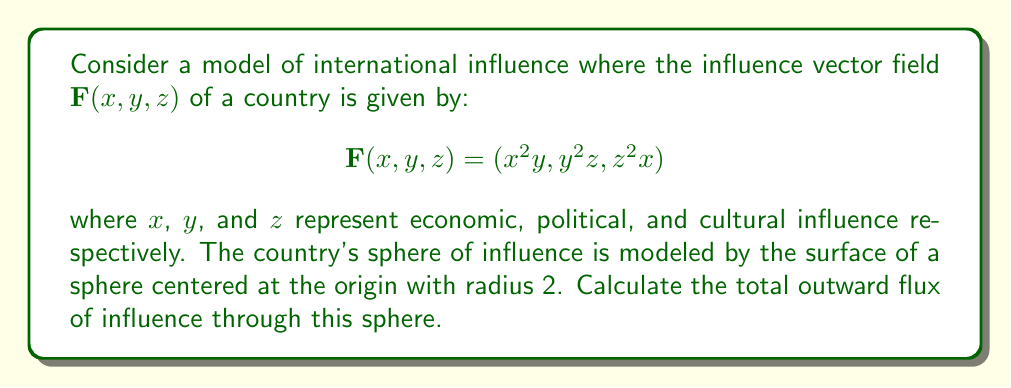Help me with this question. To solve this problem, we'll use the divergence theorem and follow these steps:

1) The divergence theorem states that the flux of a vector field $\mathbf{F}$ through a closed surface $S$ is equal to the triple integral of the divergence of $\mathbf{F}$ over the volume $V$ enclosed by $S$:

   $$\iint_S \mathbf{F} \cdot \mathbf{n} \, dS = \iiint_V \nabla \cdot \mathbf{F} \, dV$$

2) First, we need to calculate the divergence of $\mathbf{F}$:

   $$\nabla \cdot \mathbf{F} = \frac{\partial}{\partial x}(x^2y) + \frac{\partial}{\partial y}(y^2z) + \frac{\partial}{\partial z}(z^2x)$$
   $$= 2xy + 2yz + z^2$$

3) Now, we need to set up the triple integral in spherical coordinates, as the domain is a sphere. The transformation is:

   $x = r\sin\phi\cos\theta$
   $y = r\sin\phi\sin\theta$
   $z = r\cos\phi$

   where $0 \leq r \leq 2$, $0 \leq \phi \leq \pi$, and $0 \leq \theta \leq 2\pi$

4) The volume element in spherical coordinates is $r^2\sin\phi \, dr \, d\phi \, d\theta$

5) Substituting into the divergence:

   $$\nabla \cdot \mathbf{F} = 2(r\sin\phi\cos\theta)(r\sin\phi\sin\theta) + 2(r\sin\phi\sin\theta)(r\cos\phi) + r^2\cos^2\phi$$
   $$= 2r^2\sin^2\phi\cos\theta\sin\theta + 2r^2\sin\phi\cos\phi\sin\theta + r^2\cos^2\phi$$

6) Now we can set up the triple integral:

   $$\iiint_V \nabla \cdot \mathbf{F} \, dV = \int_0^{2\pi}\int_0^{\pi}\int_0^2 (2r^2\sin^2\phi\cos\theta\sin\theta + 2r^2\sin\phi\cos\phi\sin\theta + r^2\cos^2\phi) r^2\sin\phi \, dr \, d\phi \, d\theta$$

7) Integrate with respect to $r$:

   $$\int_0^{2\pi}\int_0^{\pi} (\frac{1}{2}r^5\sin^2\phi\cos\theta\sin\theta + \frac{1}{2}r^5\sin\phi\cos\phi\sin\theta + \frac{1}{4}r^5\cos^2\phi\sin\phi)\bigg|_0^2 \, d\phi \, d\theta$$

8) After evaluating at the limits of $r$, we get:

   $$\int_0^{2\pi}\int_0^{\pi} (16\sin^2\phi\cos\theta\sin\theta + 16\sin\phi\cos\phi\sin\theta + 8\cos^2\phi\sin\phi) \, d\phi \, d\theta$$

9) Integrate with respect to $\phi$:

   $$\int_0^{2\pi} (\frac{32}{3}\cos\theta\sin\theta + \frac{16}{3}\sin\theta + \frac{8}{3}) \, d\theta$$

10) Finally, integrate with respect to $\theta$:

    $$[(-\frac{32}{3}\cos\theta + \frac{16}{3}\cos\theta + \frac{8}{3}\theta)\bigg|_0^{2\pi} = \frac{16\pi}{3}$$

Therefore, the total outward flux of influence through the sphere is $\frac{16\pi}{3}$.
Answer: $\frac{16\pi}{3}$ 